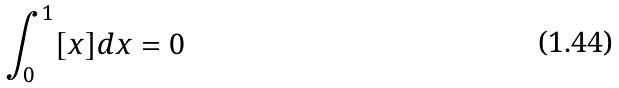<formula> <loc_0><loc_0><loc_500><loc_500>\int _ { 0 } ^ { 1 } [ x ] d x = 0</formula> 